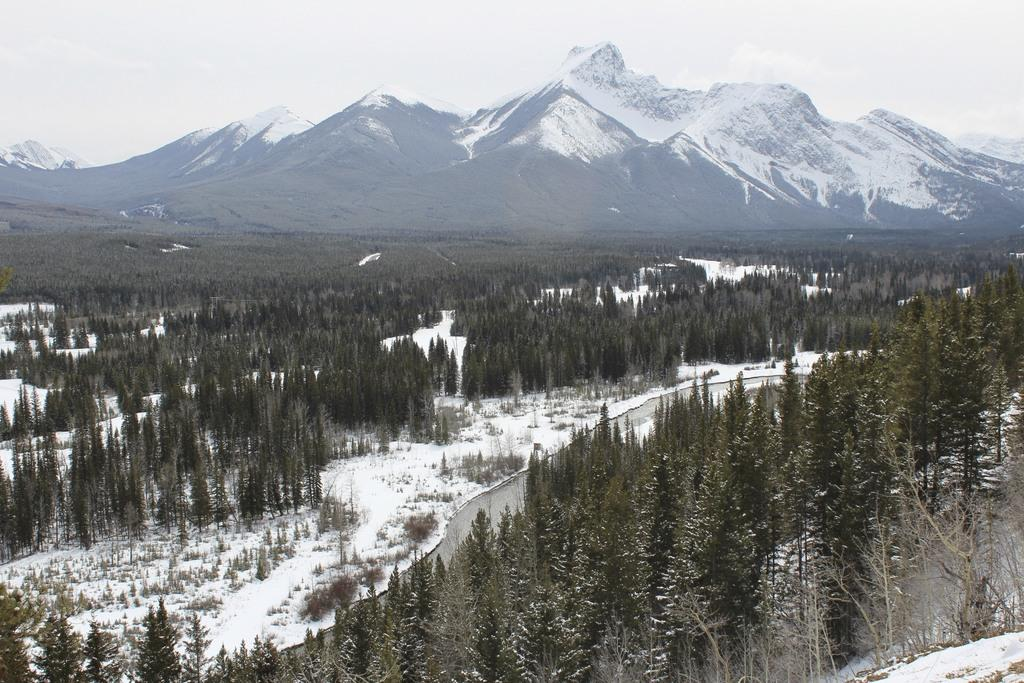What type of vegetation can be seen in the image? There are trees in the image. What is covering the ground in the image? There is snow in the image. What can be seen in the distance in the image? There is a mountain visible in the background. What is visible above the trees and mountain in the image? The sky is visible in the background. What type of copper material is present in the image? There is no copper material present in the image. Can you see any bats flying in the image? There are no bats visible in the image. 